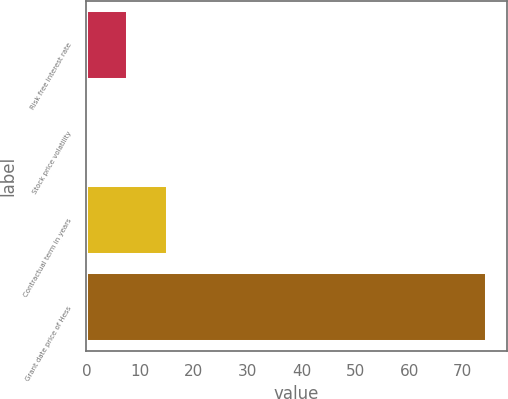<chart> <loc_0><loc_0><loc_500><loc_500><bar_chart><fcel>Risk free interest rate<fcel>Stock price volatility<fcel>Contractual term in years<fcel>Grant date price of Hess<nl><fcel>7.69<fcel>0.27<fcel>15.11<fcel>74.49<nl></chart> 